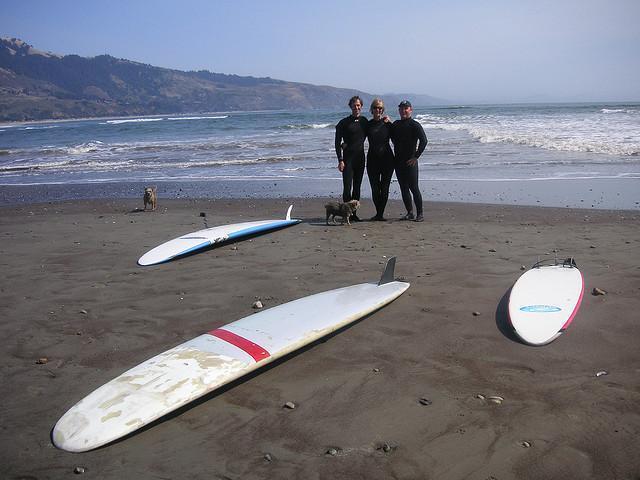How many dogs are in this photo?
Give a very brief answer. 2. How many people are there?
Give a very brief answer. 3. How many surfboards are in the photo?
Give a very brief answer. 3. 